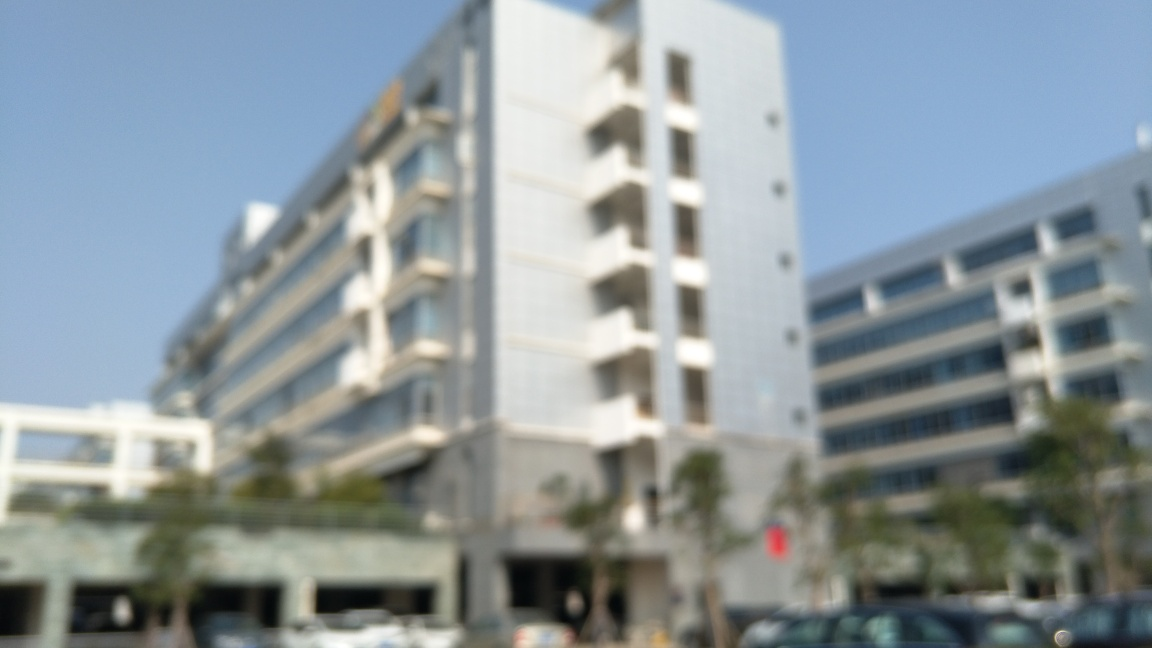Can you describe the surroundings of the building? Due to the blurriness, it's hard to provide detailed descriptions. However, the surroundings suggest an urban area with open spaces that might include parking areas or plazas in front of the building. 